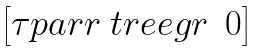Convert formula to latex. <formula><loc_0><loc_0><loc_500><loc_500>\begin{bmatrix} \tau p a r r { \ t r e e g r } & 0 \end{bmatrix}</formula> 